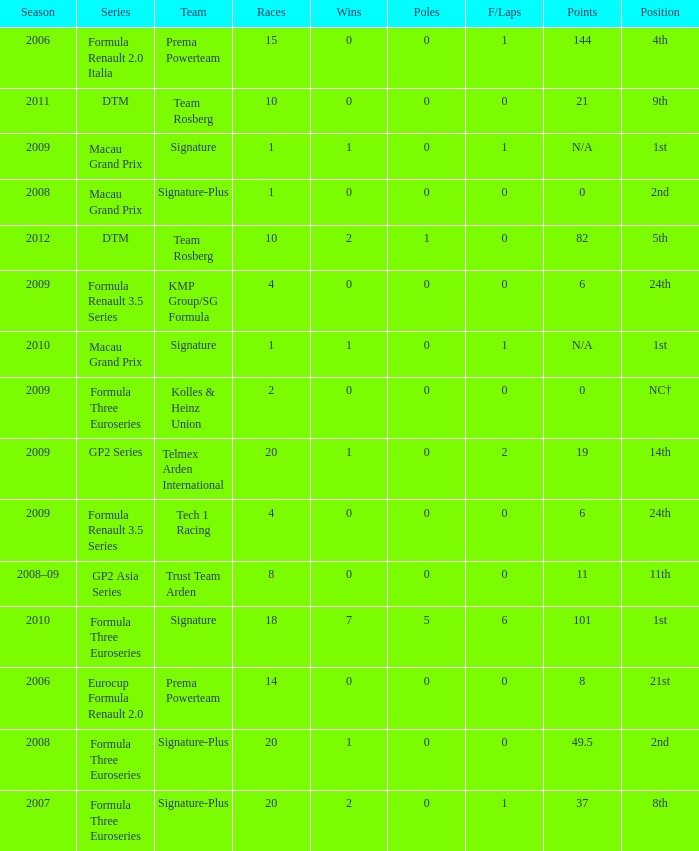How many poles are there in the Formula Three Euroseries in the 2008 season with more than 0 F/Laps? None. 